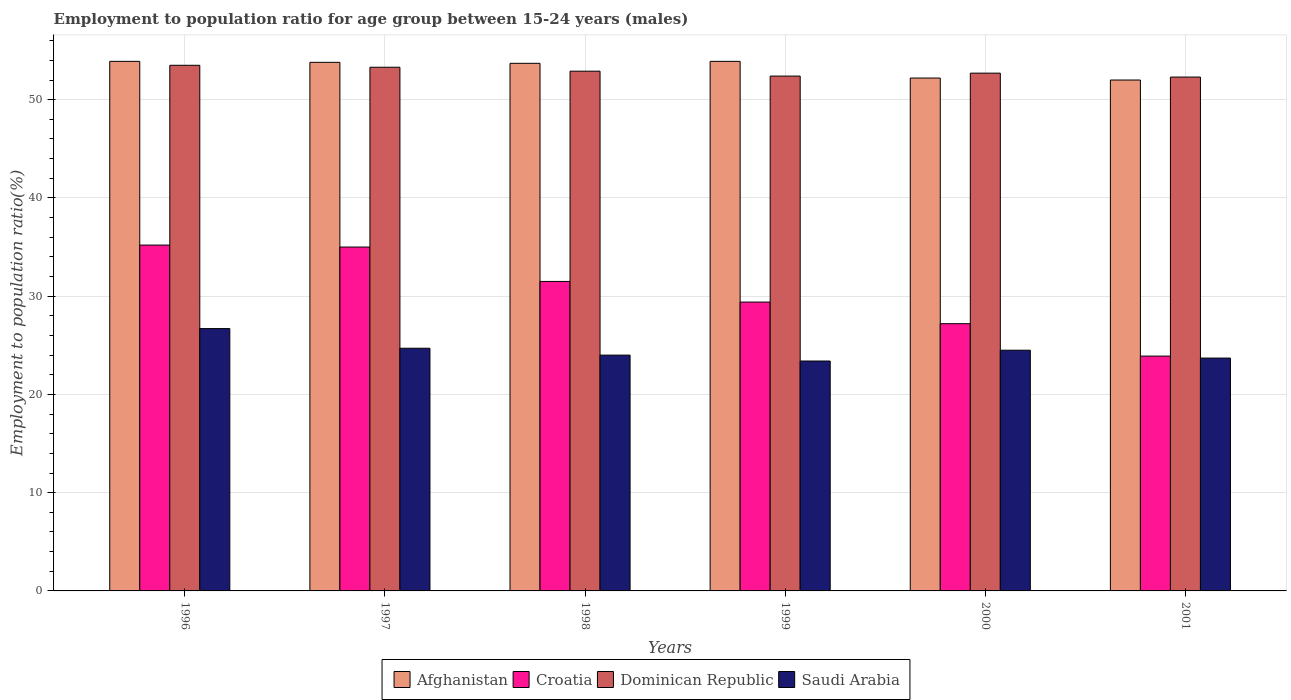How many different coloured bars are there?
Offer a terse response. 4. How many bars are there on the 5th tick from the left?
Give a very brief answer. 4. How many bars are there on the 3rd tick from the right?
Give a very brief answer. 4. What is the label of the 3rd group of bars from the left?
Your answer should be compact. 1998. In how many cases, is the number of bars for a given year not equal to the number of legend labels?
Give a very brief answer. 0. What is the employment to population ratio in Croatia in 2001?
Give a very brief answer. 23.9. Across all years, what is the maximum employment to population ratio in Afghanistan?
Ensure brevity in your answer.  53.9. Across all years, what is the minimum employment to population ratio in Croatia?
Your answer should be very brief. 23.9. In which year was the employment to population ratio in Saudi Arabia maximum?
Provide a short and direct response. 1996. In which year was the employment to population ratio in Dominican Republic minimum?
Ensure brevity in your answer.  2001. What is the total employment to population ratio in Afghanistan in the graph?
Offer a very short reply. 319.5. What is the difference between the employment to population ratio in Saudi Arabia in 1996 and that in 2000?
Give a very brief answer. 2.2. What is the difference between the employment to population ratio in Dominican Republic in 1997 and the employment to population ratio in Afghanistan in 1999?
Ensure brevity in your answer.  -0.6. What is the average employment to population ratio in Dominican Republic per year?
Your answer should be compact. 52.85. In the year 1998, what is the difference between the employment to population ratio in Dominican Republic and employment to population ratio in Afghanistan?
Give a very brief answer. -0.8. In how many years, is the employment to population ratio in Dominican Republic greater than 34 %?
Make the answer very short. 6. What is the ratio of the employment to population ratio in Saudi Arabia in 1996 to that in 2000?
Make the answer very short. 1.09. Is the difference between the employment to population ratio in Dominican Republic in 1996 and 2001 greater than the difference between the employment to population ratio in Afghanistan in 1996 and 2001?
Make the answer very short. No. What is the difference between the highest and the second highest employment to population ratio in Afghanistan?
Provide a short and direct response. 0. What is the difference between the highest and the lowest employment to population ratio in Croatia?
Keep it short and to the point. 11.3. What does the 3rd bar from the left in 1997 represents?
Ensure brevity in your answer.  Dominican Republic. What does the 4th bar from the right in 1997 represents?
Your response must be concise. Afghanistan. Is it the case that in every year, the sum of the employment to population ratio in Croatia and employment to population ratio in Saudi Arabia is greater than the employment to population ratio in Afghanistan?
Keep it short and to the point. No. How many bars are there?
Your answer should be compact. 24. What is the difference between two consecutive major ticks on the Y-axis?
Your answer should be very brief. 10. Are the values on the major ticks of Y-axis written in scientific E-notation?
Offer a terse response. No. Does the graph contain any zero values?
Your answer should be compact. No. Does the graph contain grids?
Your answer should be compact. Yes. What is the title of the graph?
Offer a very short reply. Employment to population ratio for age group between 15-24 years (males). Does "Sri Lanka" appear as one of the legend labels in the graph?
Keep it short and to the point. No. What is the label or title of the X-axis?
Provide a short and direct response. Years. What is the label or title of the Y-axis?
Your answer should be very brief. Employment to population ratio(%). What is the Employment to population ratio(%) of Afghanistan in 1996?
Provide a short and direct response. 53.9. What is the Employment to population ratio(%) of Croatia in 1996?
Keep it short and to the point. 35.2. What is the Employment to population ratio(%) in Dominican Republic in 1996?
Your answer should be compact. 53.5. What is the Employment to population ratio(%) in Saudi Arabia in 1996?
Your answer should be compact. 26.7. What is the Employment to population ratio(%) in Afghanistan in 1997?
Your response must be concise. 53.8. What is the Employment to population ratio(%) of Dominican Republic in 1997?
Offer a very short reply. 53.3. What is the Employment to population ratio(%) in Saudi Arabia in 1997?
Ensure brevity in your answer.  24.7. What is the Employment to population ratio(%) of Afghanistan in 1998?
Provide a short and direct response. 53.7. What is the Employment to population ratio(%) of Croatia in 1998?
Your answer should be very brief. 31.5. What is the Employment to population ratio(%) in Dominican Republic in 1998?
Keep it short and to the point. 52.9. What is the Employment to population ratio(%) of Afghanistan in 1999?
Provide a short and direct response. 53.9. What is the Employment to population ratio(%) of Croatia in 1999?
Make the answer very short. 29.4. What is the Employment to population ratio(%) in Dominican Republic in 1999?
Offer a terse response. 52.4. What is the Employment to population ratio(%) in Saudi Arabia in 1999?
Offer a very short reply. 23.4. What is the Employment to population ratio(%) of Afghanistan in 2000?
Your response must be concise. 52.2. What is the Employment to population ratio(%) of Croatia in 2000?
Give a very brief answer. 27.2. What is the Employment to population ratio(%) of Dominican Republic in 2000?
Your response must be concise. 52.7. What is the Employment to population ratio(%) of Saudi Arabia in 2000?
Provide a short and direct response. 24.5. What is the Employment to population ratio(%) of Afghanistan in 2001?
Give a very brief answer. 52. What is the Employment to population ratio(%) of Croatia in 2001?
Keep it short and to the point. 23.9. What is the Employment to population ratio(%) of Dominican Republic in 2001?
Make the answer very short. 52.3. What is the Employment to population ratio(%) in Saudi Arabia in 2001?
Your answer should be very brief. 23.7. Across all years, what is the maximum Employment to population ratio(%) in Afghanistan?
Offer a terse response. 53.9. Across all years, what is the maximum Employment to population ratio(%) in Croatia?
Provide a succinct answer. 35.2. Across all years, what is the maximum Employment to population ratio(%) in Dominican Republic?
Give a very brief answer. 53.5. Across all years, what is the maximum Employment to population ratio(%) in Saudi Arabia?
Your answer should be compact. 26.7. Across all years, what is the minimum Employment to population ratio(%) in Croatia?
Your response must be concise. 23.9. Across all years, what is the minimum Employment to population ratio(%) in Dominican Republic?
Ensure brevity in your answer.  52.3. Across all years, what is the minimum Employment to population ratio(%) in Saudi Arabia?
Keep it short and to the point. 23.4. What is the total Employment to population ratio(%) in Afghanistan in the graph?
Offer a terse response. 319.5. What is the total Employment to population ratio(%) in Croatia in the graph?
Your answer should be compact. 182.2. What is the total Employment to population ratio(%) of Dominican Republic in the graph?
Provide a short and direct response. 317.1. What is the total Employment to population ratio(%) in Saudi Arabia in the graph?
Provide a short and direct response. 147. What is the difference between the Employment to population ratio(%) in Afghanistan in 1996 and that in 1997?
Provide a short and direct response. 0.1. What is the difference between the Employment to population ratio(%) of Saudi Arabia in 1996 and that in 1997?
Make the answer very short. 2. What is the difference between the Employment to population ratio(%) in Croatia in 1996 and that in 1998?
Give a very brief answer. 3.7. What is the difference between the Employment to population ratio(%) in Dominican Republic in 1996 and that in 1998?
Offer a terse response. 0.6. What is the difference between the Employment to population ratio(%) in Afghanistan in 1996 and that in 1999?
Offer a terse response. 0. What is the difference between the Employment to population ratio(%) of Dominican Republic in 1996 and that in 1999?
Keep it short and to the point. 1.1. What is the difference between the Employment to population ratio(%) of Afghanistan in 1996 and that in 2000?
Your answer should be compact. 1.7. What is the difference between the Employment to population ratio(%) of Saudi Arabia in 1996 and that in 2000?
Your answer should be compact. 2.2. What is the difference between the Employment to population ratio(%) in Saudi Arabia in 1996 and that in 2001?
Ensure brevity in your answer.  3. What is the difference between the Employment to population ratio(%) in Afghanistan in 1997 and that in 1998?
Offer a very short reply. 0.1. What is the difference between the Employment to population ratio(%) in Croatia in 1997 and that in 1998?
Give a very brief answer. 3.5. What is the difference between the Employment to population ratio(%) of Dominican Republic in 1997 and that in 1998?
Make the answer very short. 0.4. What is the difference between the Employment to population ratio(%) of Saudi Arabia in 1997 and that in 1998?
Ensure brevity in your answer.  0.7. What is the difference between the Employment to population ratio(%) in Dominican Republic in 1997 and that in 1999?
Your response must be concise. 0.9. What is the difference between the Employment to population ratio(%) in Croatia in 1997 and that in 2000?
Provide a short and direct response. 7.8. What is the difference between the Employment to population ratio(%) in Saudi Arabia in 1997 and that in 2000?
Keep it short and to the point. 0.2. What is the difference between the Employment to population ratio(%) of Afghanistan in 1997 and that in 2001?
Ensure brevity in your answer.  1.8. What is the difference between the Employment to population ratio(%) of Croatia in 1997 and that in 2001?
Offer a very short reply. 11.1. What is the difference between the Employment to population ratio(%) of Saudi Arabia in 1997 and that in 2001?
Your answer should be very brief. 1. What is the difference between the Employment to population ratio(%) of Croatia in 1998 and that in 1999?
Offer a very short reply. 2.1. What is the difference between the Employment to population ratio(%) in Saudi Arabia in 1998 and that in 1999?
Ensure brevity in your answer.  0.6. What is the difference between the Employment to population ratio(%) of Afghanistan in 1998 and that in 2000?
Your answer should be compact. 1.5. What is the difference between the Employment to population ratio(%) of Croatia in 1998 and that in 2000?
Offer a very short reply. 4.3. What is the difference between the Employment to population ratio(%) of Dominican Republic in 1998 and that in 2000?
Make the answer very short. 0.2. What is the difference between the Employment to population ratio(%) of Saudi Arabia in 1998 and that in 2000?
Offer a terse response. -0.5. What is the difference between the Employment to population ratio(%) of Dominican Republic in 1998 and that in 2001?
Ensure brevity in your answer.  0.6. What is the difference between the Employment to population ratio(%) in Afghanistan in 1999 and that in 2000?
Provide a succinct answer. 1.7. What is the difference between the Employment to population ratio(%) of Croatia in 1999 and that in 2000?
Provide a succinct answer. 2.2. What is the difference between the Employment to population ratio(%) of Dominican Republic in 1999 and that in 2000?
Provide a short and direct response. -0.3. What is the difference between the Employment to population ratio(%) of Croatia in 1999 and that in 2001?
Make the answer very short. 5.5. What is the difference between the Employment to population ratio(%) of Saudi Arabia in 1999 and that in 2001?
Make the answer very short. -0.3. What is the difference between the Employment to population ratio(%) in Saudi Arabia in 2000 and that in 2001?
Offer a terse response. 0.8. What is the difference between the Employment to population ratio(%) in Afghanistan in 1996 and the Employment to population ratio(%) in Dominican Republic in 1997?
Offer a terse response. 0.6. What is the difference between the Employment to population ratio(%) in Afghanistan in 1996 and the Employment to population ratio(%) in Saudi Arabia in 1997?
Make the answer very short. 29.2. What is the difference between the Employment to population ratio(%) of Croatia in 1996 and the Employment to population ratio(%) of Dominican Republic in 1997?
Ensure brevity in your answer.  -18.1. What is the difference between the Employment to population ratio(%) of Dominican Republic in 1996 and the Employment to population ratio(%) of Saudi Arabia in 1997?
Offer a terse response. 28.8. What is the difference between the Employment to population ratio(%) in Afghanistan in 1996 and the Employment to population ratio(%) in Croatia in 1998?
Offer a very short reply. 22.4. What is the difference between the Employment to population ratio(%) of Afghanistan in 1996 and the Employment to population ratio(%) of Dominican Republic in 1998?
Provide a short and direct response. 1. What is the difference between the Employment to population ratio(%) in Afghanistan in 1996 and the Employment to population ratio(%) in Saudi Arabia in 1998?
Offer a terse response. 29.9. What is the difference between the Employment to population ratio(%) in Croatia in 1996 and the Employment to population ratio(%) in Dominican Republic in 1998?
Your answer should be very brief. -17.7. What is the difference between the Employment to population ratio(%) in Dominican Republic in 1996 and the Employment to population ratio(%) in Saudi Arabia in 1998?
Your answer should be very brief. 29.5. What is the difference between the Employment to population ratio(%) in Afghanistan in 1996 and the Employment to population ratio(%) in Croatia in 1999?
Give a very brief answer. 24.5. What is the difference between the Employment to population ratio(%) of Afghanistan in 1996 and the Employment to population ratio(%) of Saudi Arabia in 1999?
Make the answer very short. 30.5. What is the difference between the Employment to population ratio(%) of Croatia in 1996 and the Employment to population ratio(%) of Dominican Republic in 1999?
Provide a short and direct response. -17.2. What is the difference between the Employment to population ratio(%) in Croatia in 1996 and the Employment to population ratio(%) in Saudi Arabia in 1999?
Provide a succinct answer. 11.8. What is the difference between the Employment to population ratio(%) of Dominican Republic in 1996 and the Employment to population ratio(%) of Saudi Arabia in 1999?
Your response must be concise. 30.1. What is the difference between the Employment to population ratio(%) of Afghanistan in 1996 and the Employment to population ratio(%) of Croatia in 2000?
Your answer should be very brief. 26.7. What is the difference between the Employment to population ratio(%) in Afghanistan in 1996 and the Employment to population ratio(%) in Dominican Republic in 2000?
Your answer should be very brief. 1.2. What is the difference between the Employment to population ratio(%) in Afghanistan in 1996 and the Employment to population ratio(%) in Saudi Arabia in 2000?
Keep it short and to the point. 29.4. What is the difference between the Employment to population ratio(%) of Croatia in 1996 and the Employment to population ratio(%) of Dominican Republic in 2000?
Your answer should be very brief. -17.5. What is the difference between the Employment to population ratio(%) of Dominican Republic in 1996 and the Employment to population ratio(%) of Saudi Arabia in 2000?
Make the answer very short. 29. What is the difference between the Employment to population ratio(%) of Afghanistan in 1996 and the Employment to population ratio(%) of Croatia in 2001?
Your response must be concise. 30. What is the difference between the Employment to population ratio(%) of Afghanistan in 1996 and the Employment to population ratio(%) of Saudi Arabia in 2001?
Your answer should be very brief. 30.2. What is the difference between the Employment to population ratio(%) of Croatia in 1996 and the Employment to population ratio(%) of Dominican Republic in 2001?
Make the answer very short. -17.1. What is the difference between the Employment to population ratio(%) in Dominican Republic in 1996 and the Employment to population ratio(%) in Saudi Arabia in 2001?
Offer a terse response. 29.8. What is the difference between the Employment to population ratio(%) of Afghanistan in 1997 and the Employment to population ratio(%) of Croatia in 1998?
Keep it short and to the point. 22.3. What is the difference between the Employment to population ratio(%) of Afghanistan in 1997 and the Employment to population ratio(%) of Saudi Arabia in 1998?
Your response must be concise. 29.8. What is the difference between the Employment to population ratio(%) in Croatia in 1997 and the Employment to population ratio(%) in Dominican Republic in 1998?
Make the answer very short. -17.9. What is the difference between the Employment to population ratio(%) of Dominican Republic in 1997 and the Employment to population ratio(%) of Saudi Arabia in 1998?
Ensure brevity in your answer.  29.3. What is the difference between the Employment to population ratio(%) of Afghanistan in 1997 and the Employment to population ratio(%) of Croatia in 1999?
Offer a very short reply. 24.4. What is the difference between the Employment to population ratio(%) of Afghanistan in 1997 and the Employment to population ratio(%) of Dominican Republic in 1999?
Provide a short and direct response. 1.4. What is the difference between the Employment to population ratio(%) of Afghanistan in 1997 and the Employment to population ratio(%) of Saudi Arabia in 1999?
Your answer should be very brief. 30.4. What is the difference between the Employment to population ratio(%) in Croatia in 1997 and the Employment to population ratio(%) in Dominican Republic in 1999?
Keep it short and to the point. -17.4. What is the difference between the Employment to population ratio(%) in Croatia in 1997 and the Employment to population ratio(%) in Saudi Arabia in 1999?
Offer a terse response. 11.6. What is the difference between the Employment to population ratio(%) in Dominican Republic in 1997 and the Employment to population ratio(%) in Saudi Arabia in 1999?
Provide a succinct answer. 29.9. What is the difference between the Employment to population ratio(%) in Afghanistan in 1997 and the Employment to population ratio(%) in Croatia in 2000?
Offer a very short reply. 26.6. What is the difference between the Employment to population ratio(%) of Afghanistan in 1997 and the Employment to population ratio(%) of Saudi Arabia in 2000?
Your answer should be compact. 29.3. What is the difference between the Employment to population ratio(%) in Croatia in 1997 and the Employment to population ratio(%) in Dominican Republic in 2000?
Ensure brevity in your answer.  -17.7. What is the difference between the Employment to population ratio(%) of Croatia in 1997 and the Employment to population ratio(%) of Saudi Arabia in 2000?
Your answer should be compact. 10.5. What is the difference between the Employment to population ratio(%) of Dominican Republic in 1997 and the Employment to population ratio(%) of Saudi Arabia in 2000?
Make the answer very short. 28.8. What is the difference between the Employment to population ratio(%) in Afghanistan in 1997 and the Employment to population ratio(%) in Croatia in 2001?
Offer a terse response. 29.9. What is the difference between the Employment to population ratio(%) in Afghanistan in 1997 and the Employment to population ratio(%) in Saudi Arabia in 2001?
Make the answer very short. 30.1. What is the difference between the Employment to population ratio(%) of Croatia in 1997 and the Employment to population ratio(%) of Dominican Republic in 2001?
Keep it short and to the point. -17.3. What is the difference between the Employment to population ratio(%) in Dominican Republic in 1997 and the Employment to population ratio(%) in Saudi Arabia in 2001?
Your response must be concise. 29.6. What is the difference between the Employment to population ratio(%) in Afghanistan in 1998 and the Employment to population ratio(%) in Croatia in 1999?
Make the answer very short. 24.3. What is the difference between the Employment to population ratio(%) of Afghanistan in 1998 and the Employment to population ratio(%) of Saudi Arabia in 1999?
Offer a very short reply. 30.3. What is the difference between the Employment to population ratio(%) in Croatia in 1998 and the Employment to population ratio(%) in Dominican Republic in 1999?
Give a very brief answer. -20.9. What is the difference between the Employment to population ratio(%) of Dominican Republic in 1998 and the Employment to population ratio(%) of Saudi Arabia in 1999?
Make the answer very short. 29.5. What is the difference between the Employment to population ratio(%) in Afghanistan in 1998 and the Employment to population ratio(%) in Croatia in 2000?
Provide a succinct answer. 26.5. What is the difference between the Employment to population ratio(%) in Afghanistan in 1998 and the Employment to population ratio(%) in Saudi Arabia in 2000?
Give a very brief answer. 29.2. What is the difference between the Employment to population ratio(%) in Croatia in 1998 and the Employment to population ratio(%) in Dominican Republic in 2000?
Offer a very short reply. -21.2. What is the difference between the Employment to population ratio(%) in Croatia in 1998 and the Employment to population ratio(%) in Saudi Arabia in 2000?
Provide a short and direct response. 7. What is the difference between the Employment to population ratio(%) of Dominican Republic in 1998 and the Employment to population ratio(%) of Saudi Arabia in 2000?
Your answer should be very brief. 28.4. What is the difference between the Employment to population ratio(%) of Afghanistan in 1998 and the Employment to population ratio(%) of Croatia in 2001?
Your answer should be compact. 29.8. What is the difference between the Employment to population ratio(%) of Croatia in 1998 and the Employment to population ratio(%) of Dominican Republic in 2001?
Offer a very short reply. -20.8. What is the difference between the Employment to population ratio(%) of Dominican Republic in 1998 and the Employment to population ratio(%) of Saudi Arabia in 2001?
Make the answer very short. 29.2. What is the difference between the Employment to population ratio(%) of Afghanistan in 1999 and the Employment to population ratio(%) of Croatia in 2000?
Provide a succinct answer. 26.7. What is the difference between the Employment to population ratio(%) of Afghanistan in 1999 and the Employment to population ratio(%) of Saudi Arabia in 2000?
Your answer should be very brief. 29.4. What is the difference between the Employment to population ratio(%) in Croatia in 1999 and the Employment to population ratio(%) in Dominican Republic in 2000?
Your answer should be very brief. -23.3. What is the difference between the Employment to population ratio(%) of Croatia in 1999 and the Employment to population ratio(%) of Saudi Arabia in 2000?
Offer a very short reply. 4.9. What is the difference between the Employment to population ratio(%) in Dominican Republic in 1999 and the Employment to population ratio(%) in Saudi Arabia in 2000?
Give a very brief answer. 27.9. What is the difference between the Employment to population ratio(%) in Afghanistan in 1999 and the Employment to population ratio(%) in Saudi Arabia in 2001?
Ensure brevity in your answer.  30.2. What is the difference between the Employment to population ratio(%) in Croatia in 1999 and the Employment to population ratio(%) in Dominican Republic in 2001?
Ensure brevity in your answer.  -22.9. What is the difference between the Employment to population ratio(%) of Croatia in 1999 and the Employment to population ratio(%) of Saudi Arabia in 2001?
Your answer should be very brief. 5.7. What is the difference between the Employment to population ratio(%) in Dominican Republic in 1999 and the Employment to population ratio(%) in Saudi Arabia in 2001?
Provide a short and direct response. 28.7. What is the difference between the Employment to population ratio(%) in Afghanistan in 2000 and the Employment to population ratio(%) in Croatia in 2001?
Your response must be concise. 28.3. What is the difference between the Employment to population ratio(%) of Afghanistan in 2000 and the Employment to population ratio(%) of Dominican Republic in 2001?
Your answer should be very brief. -0.1. What is the difference between the Employment to population ratio(%) of Afghanistan in 2000 and the Employment to population ratio(%) of Saudi Arabia in 2001?
Your answer should be compact. 28.5. What is the difference between the Employment to population ratio(%) in Croatia in 2000 and the Employment to population ratio(%) in Dominican Republic in 2001?
Your answer should be compact. -25.1. What is the difference between the Employment to population ratio(%) of Croatia in 2000 and the Employment to population ratio(%) of Saudi Arabia in 2001?
Make the answer very short. 3.5. What is the average Employment to population ratio(%) in Afghanistan per year?
Give a very brief answer. 53.25. What is the average Employment to population ratio(%) of Croatia per year?
Ensure brevity in your answer.  30.37. What is the average Employment to population ratio(%) of Dominican Republic per year?
Your response must be concise. 52.85. What is the average Employment to population ratio(%) of Saudi Arabia per year?
Ensure brevity in your answer.  24.5. In the year 1996, what is the difference between the Employment to population ratio(%) of Afghanistan and Employment to population ratio(%) of Croatia?
Ensure brevity in your answer.  18.7. In the year 1996, what is the difference between the Employment to population ratio(%) of Afghanistan and Employment to population ratio(%) of Saudi Arabia?
Offer a very short reply. 27.2. In the year 1996, what is the difference between the Employment to population ratio(%) of Croatia and Employment to population ratio(%) of Dominican Republic?
Give a very brief answer. -18.3. In the year 1996, what is the difference between the Employment to population ratio(%) in Dominican Republic and Employment to population ratio(%) in Saudi Arabia?
Make the answer very short. 26.8. In the year 1997, what is the difference between the Employment to population ratio(%) of Afghanistan and Employment to population ratio(%) of Croatia?
Keep it short and to the point. 18.8. In the year 1997, what is the difference between the Employment to population ratio(%) of Afghanistan and Employment to population ratio(%) of Saudi Arabia?
Your answer should be very brief. 29.1. In the year 1997, what is the difference between the Employment to population ratio(%) of Croatia and Employment to population ratio(%) of Dominican Republic?
Provide a succinct answer. -18.3. In the year 1997, what is the difference between the Employment to population ratio(%) of Dominican Republic and Employment to population ratio(%) of Saudi Arabia?
Make the answer very short. 28.6. In the year 1998, what is the difference between the Employment to population ratio(%) of Afghanistan and Employment to population ratio(%) of Croatia?
Offer a terse response. 22.2. In the year 1998, what is the difference between the Employment to population ratio(%) in Afghanistan and Employment to population ratio(%) in Dominican Republic?
Ensure brevity in your answer.  0.8. In the year 1998, what is the difference between the Employment to population ratio(%) of Afghanistan and Employment to population ratio(%) of Saudi Arabia?
Provide a succinct answer. 29.7. In the year 1998, what is the difference between the Employment to population ratio(%) in Croatia and Employment to population ratio(%) in Dominican Republic?
Your answer should be compact. -21.4. In the year 1998, what is the difference between the Employment to population ratio(%) in Dominican Republic and Employment to population ratio(%) in Saudi Arabia?
Ensure brevity in your answer.  28.9. In the year 1999, what is the difference between the Employment to population ratio(%) of Afghanistan and Employment to population ratio(%) of Croatia?
Provide a succinct answer. 24.5. In the year 1999, what is the difference between the Employment to population ratio(%) of Afghanistan and Employment to population ratio(%) of Dominican Republic?
Offer a very short reply. 1.5. In the year 1999, what is the difference between the Employment to population ratio(%) in Afghanistan and Employment to population ratio(%) in Saudi Arabia?
Offer a terse response. 30.5. In the year 1999, what is the difference between the Employment to population ratio(%) of Croatia and Employment to population ratio(%) of Saudi Arabia?
Offer a terse response. 6. In the year 2000, what is the difference between the Employment to population ratio(%) in Afghanistan and Employment to population ratio(%) in Saudi Arabia?
Ensure brevity in your answer.  27.7. In the year 2000, what is the difference between the Employment to population ratio(%) in Croatia and Employment to population ratio(%) in Dominican Republic?
Give a very brief answer. -25.5. In the year 2000, what is the difference between the Employment to population ratio(%) in Dominican Republic and Employment to population ratio(%) in Saudi Arabia?
Make the answer very short. 28.2. In the year 2001, what is the difference between the Employment to population ratio(%) in Afghanistan and Employment to population ratio(%) in Croatia?
Provide a succinct answer. 28.1. In the year 2001, what is the difference between the Employment to population ratio(%) of Afghanistan and Employment to population ratio(%) of Saudi Arabia?
Provide a short and direct response. 28.3. In the year 2001, what is the difference between the Employment to population ratio(%) of Croatia and Employment to population ratio(%) of Dominican Republic?
Keep it short and to the point. -28.4. In the year 2001, what is the difference between the Employment to population ratio(%) in Dominican Republic and Employment to population ratio(%) in Saudi Arabia?
Give a very brief answer. 28.6. What is the ratio of the Employment to population ratio(%) in Afghanistan in 1996 to that in 1997?
Your answer should be very brief. 1. What is the ratio of the Employment to population ratio(%) in Saudi Arabia in 1996 to that in 1997?
Make the answer very short. 1.08. What is the ratio of the Employment to population ratio(%) of Afghanistan in 1996 to that in 1998?
Ensure brevity in your answer.  1. What is the ratio of the Employment to population ratio(%) in Croatia in 1996 to that in 1998?
Your response must be concise. 1.12. What is the ratio of the Employment to population ratio(%) of Dominican Republic in 1996 to that in 1998?
Your response must be concise. 1.01. What is the ratio of the Employment to population ratio(%) in Saudi Arabia in 1996 to that in 1998?
Ensure brevity in your answer.  1.11. What is the ratio of the Employment to population ratio(%) of Croatia in 1996 to that in 1999?
Offer a very short reply. 1.2. What is the ratio of the Employment to population ratio(%) in Dominican Republic in 1996 to that in 1999?
Your answer should be very brief. 1.02. What is the ratio of the Employment to population ratio(%) of Saudi Arabia in 1996 to that in 1999?
Offer a terse response. 1.14. What is the ratio of the Employment to population ratio(%) in Afghanistan in 1996 to that in 2000?
Ensure brevity in your answer.  1.03. What is the ratio of the Employment to population ratio(%) in Croatia in 1996 to that in 2000?
Ensure brevity in your answer.  1.29. What is the ratio of the Employment to population ratio(%) of Dominican Republic in 1996 to that in 2000?
Keep it short and to the point. 1.02. What is the ratio of the Employment to population ratio(%) of Saudi Arabia in 1996 to that in 2000?
Provide a short and direct response. 1.09. What is the ratio of the Employment to population ratio(%) in Afghanistan in 1996 to that in 2001?
Your answer should be compact. 1.04. What is the ratio of the Employment to population ratio(%) in Croatia in 1996 to that in 2001?
Ensure brevity in your answer.  1.47. What is the ratio of the Employment to population ratio(%) of Dominican Republic in 1996 to that in 2001?
Offer a very short reply. 1.02. What is the ratio of the Employment to population ratio(%) in Saudi Arabia in 1996 to that in 2001?
Provide a succinct answer. 1.13. What is the ratio of the Employment to population ratio(%) in Afghanistan in 1997 to that in 1998?
Give a very brief answer. 1. What is the ratio of the Employment to population ratio(%) of Dominican Republic in 1997 to that in 1998?
Give a very brief answer. 1.01. What is the ratio of the Employment to population ratio(%) of Saudi Arabia in 1997 to that in 1998?
Provide a short and direct response. 1.03. What is the ratio of the Employment to population ratio(%) in Afghanistan in 1997 to that in 1999?
Ensure brevity in your answer.  1. What is the ratio of the Employment to population ratio(%) of Croatia in 1997 to that in 1999?
Keep it short and to the point. 1.19. What is the ratio of the Employment to population ratio(%) of Dominican Republic in 1997 to that in 1999?
Give a very brief answer. 1.02. What is the ratio of the Employment to population ratio(%) in Saudi Arabia in 1997 to that in 1999?
Offer a terse response. 1.06. What is the ratio of the Employment to population ratio(%) in Afghanistan in 1997 to that in 2000?
Your answer should be very brief. 1.03. What is the ratio of the Employment to population ratio(%) in Croatia in 1997 to that in 2000?
Your response must be concise. 1.29. What is the ratio of the Employment to population ratio(%) of Dominican Republic in 1997 to that in 2000?
Offer a very short reply. 1.01. What is the ratio of the Employment to population ratio(%) of Saudi Arabia in 1997 to that in 2000?
Offer a terse response. 1.01. What is the ratio of the Employment to population ratio(%) of Afghanistan in 1997 to that in 2001?
Your response must be concise. 1.03. What is the ratio of the Employment to population ratio(%) in Croatia in 1997 to that in 2001?
Give a very brief answer. 1.46. What is the ratio of the Employment to population ratio(%) of Dominican Republic in 1997 to that in 2001?
Your answer should be very brief. 1.02. What is the ratio of the Employment to population ratio(%) in Saudi Arabia in 1997 to that in 2001?
Make the answer very short. 1.04. What is the ratio of the Employment to population ratio(%) in Afghanistan in 1998 to that in 1999?
Make the answer very short. 1. What is the ratio of the Employment to population ratio(%) in Croatia in 1998 to that in 1999?
Give a very brief answer. 1.07. What is the ratio of the Employment to population ratio(%) in Dominican Republic in 1998 to that in 1999?
Make the answer very short. 1.01. What is the ratio of the Employment to population ratio(%) in Saudi Arabia in 1998 to that in 1999?
Ensure brevity in your answer.  1.03. What is the ratio of the Employment to population ratio(%) of Afghanistan in 1998 to that in 2000?
Give a very brief answer. 1.03. What is the ratio of the Employment to population ratio(%) in Croatia in 1998 to that in 2000?
Provide a short and direct response. 1.16. What is the ratio of the Employment to population ratio(%) of Dominican Republic in 1998 to that in 2000?
Provide a short and direct response. 1. What is the ratio of the Employment to population ratio(%) in Saudi Arabia in 1998 to that in 2000?
Offer a terse response. 0.98. What is the ratio of the Employment to population ratio(%) of Afghanistan in 1998 to that in 2001?
Keep it short and to the point. 1.03. What is the ratio of the Employment to population ratio(%) of Croatia in 1998 to that in 2001?
Your answer should be very brief. 1.32. What is the ratio of the Employment to population ratio(%) in Dominican Republic in 1998 to that in 2001?
Provide a succinct answer. 1.01. What is the ratio of the Employment to population ratio(%) in Saudi Arabia in 1998 to that in 2001?
Your answer should be very brief. 1.01. What is the ratio of the Employment to population ratio(%) of Afghanistan in 1999 to that in 2000?
Your response must be concise. 1.03. What is the ratio of the Employment to population ratio(%) of Croatia in 1999 to that in 2000?
Your answer should be very brief. 1.08. What is the ratio of the Employment to population ratio(%) of Saudi Arabia in 1999 to that in 2000?
Provide a short and direct response. 0.96. What is the ratio of the Employment to population ratio(%) of Afghanistan in 1999 to that in 2001?
Your response must be concise. 1.04. What is the ratio of the Employment to population ratio(%) in Croatia in 1999 to that in 2001?
Make the answer very short. 1.23. What is the ratio of the Employment to population ratio(%) of Dominican Republic in 1999 to that in 2001?
Give a very brief answer. 1. What is the ratio of the Employment to population ratio(%) in Saudi Arabia in 1999 to that in 2001?
Your response must be concise. 0.99. What is the ratio of the Employment to population ratio(%) of Croatia in 2000 to that in 2001?
Ensure brevity in your answer.  1.14. What is the ratio of the Employment to population ratio(%) of Dominican Republic in 2000 to that in 2001?
Offer a very short reply. 1.01. What is the ratio of the Employment to population ratio(%) of Saudi Arabia in 2000 to that in 2001?
Make the answer very short. 1.03. What is the difference between the highest and the second highest Employment to population ratio(%) in Croatia?
Your response must be concise. 0.2. What is the difference between the highest and the second highest Employment to population ratio(%) in Saudi Arabia?
Make the answer very short. 2. What is the difference between the highest and the lowest Employment to population ratio(%) of Afghanistan?
Offer a terse response. 1.9. 